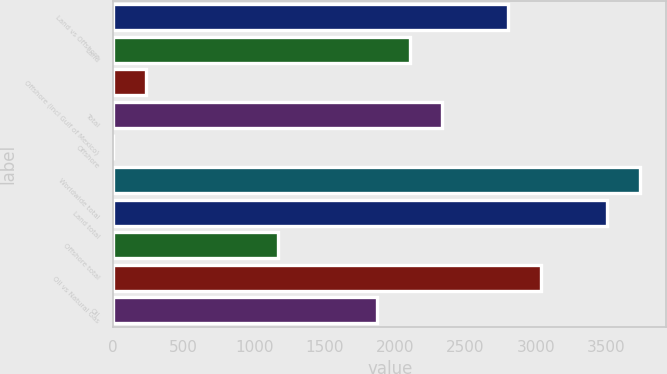<chart> <loc_0><loc_0><loc_500><loc_500><bar_chart><fcel>Land vs Offshore<fcel>Land<fcel>Offshore (incl Gulf of Mexico)<fcel>Total<fcel>Offshore<fcel>Worldwide total<fcel>Land total<fcel>Offshore total<fcel>Oil vs Natural Gas<fcel>Oil<nl><fcel>2802.8<fcel>2102.6<fcel>235.4<fcel>2336<fcel>2<fcel>3736.4<fcel>3503<fcel>1169<fcel>3036.2<fcel>1869.2<nl></chart> 